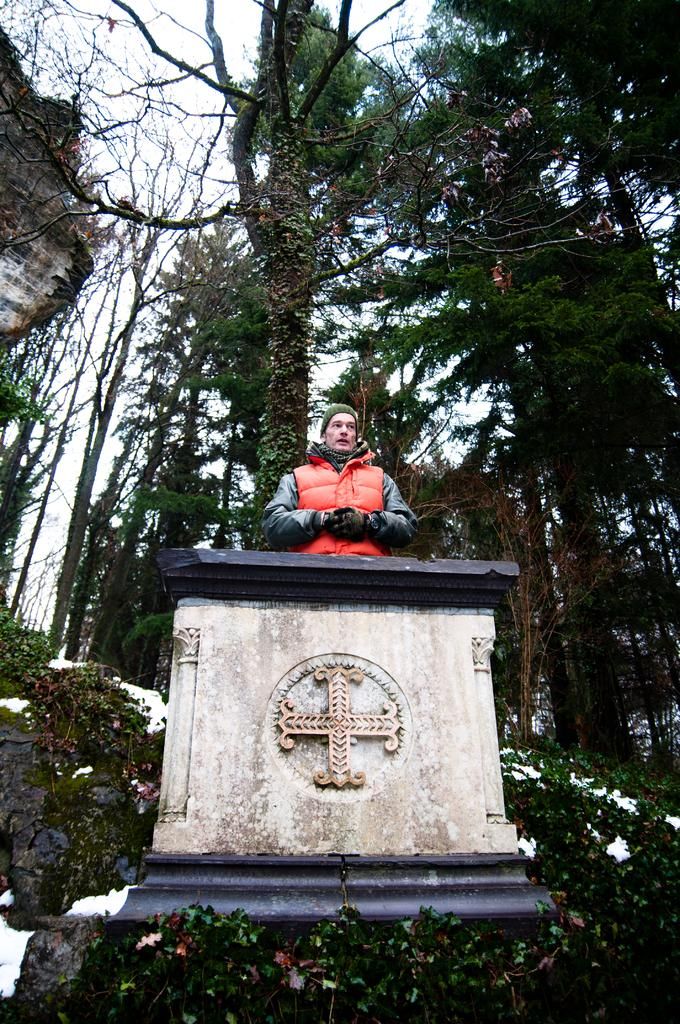What is located at the bottom of the image? There is a statue at the bottom of the image. What can be seen in the background of the image? There are trees in the background of the image. What is visible at the top of the image? The sky is visible at the top of the image. What time is depicted in the image? The image does not depict a specific time or hour; it is a static representation. 